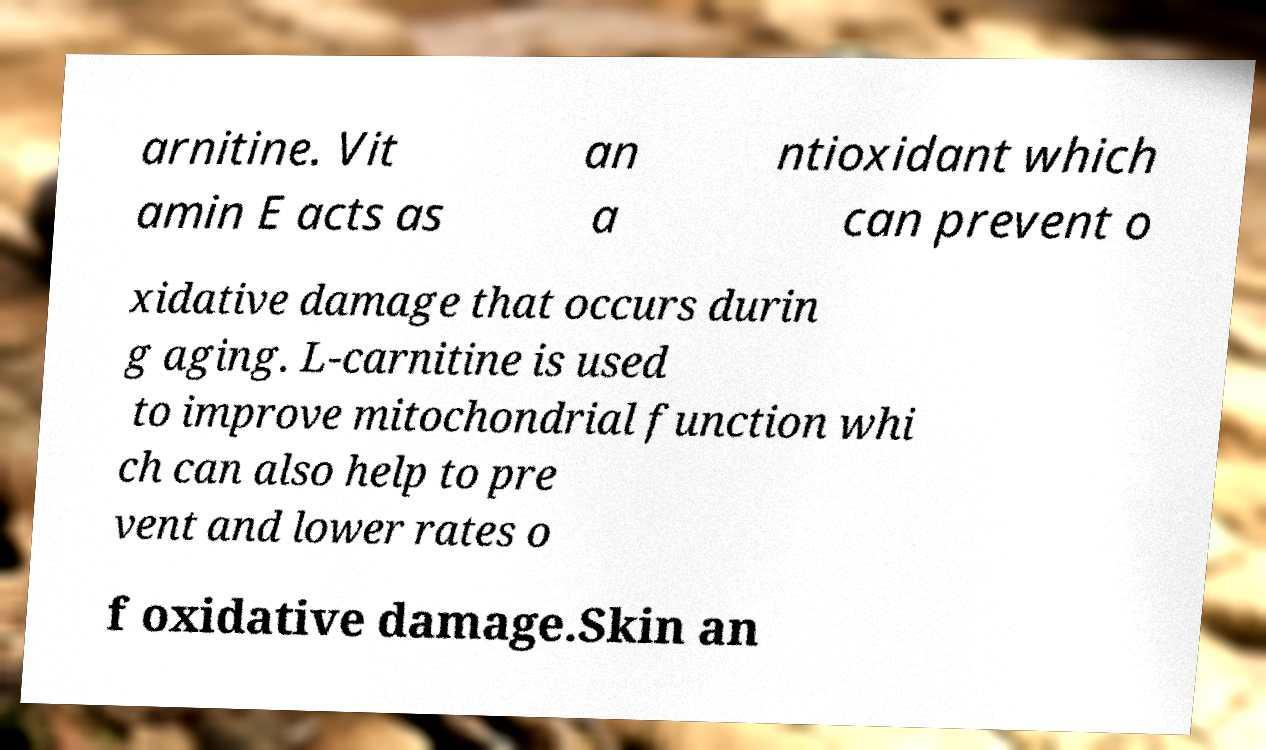Could you extract and type out the text from this image? arnitine. Vit amin E acts as an a ntioxidant which can prevent o xidative damage that occurs durin g aging. L-carnitine is used to improve mitochondrial function whi ch can also help to pre vent and lower rates o f oxidative damage.Skin an 